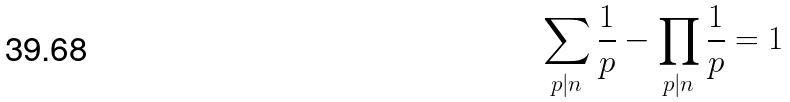<formula> <loc_0><loc_0><loc_500><loc_500>\sum _ { p | n } \frac { 1 } { p } - \prod _ { p | n } \frac { 1 } { p } = 1</formula> 